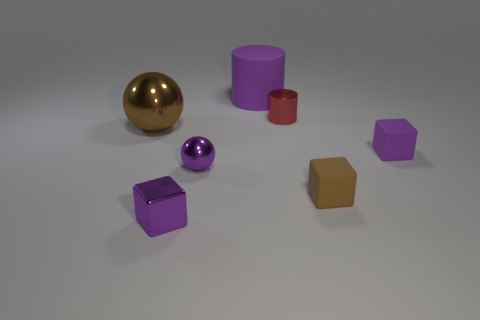Add 2 brown rubber objects. How many objects exist? 9 Subtract all cubes. How many objects are left? 4 Subtract all small purple matte things. Subtract all matte things. How many objects are left? 3 Add 7 big brown metallic spheres. How many big brown metallic spheres are left? 8 Add 3 red rubber balls. How many red rubber balls exist? 3 Subtract 0 gray blocks. How many objects are left? 7 